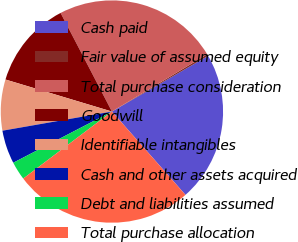Convert chart to OTSL. <chart><loc_0><loc_0><loc_500><loc_500><pie_chart><fcel>Cash paid<fcel>Fair value of assumed equity<fcel>Total purchase consideration<fcel>Goodwill<fcel>Identifiable intangibles<fcel>Cash and other assets acquired<fcel>Debt and liabilities assumed<fcel>Total purchase allocation<nl><fcel>21.84%<fcel>0.27%<fcel>24.02%<fcel>12.71%<fcel>7.41%<fcel>4.86%<fcel>2.68%<fcel>26.21%<nl></chart> 